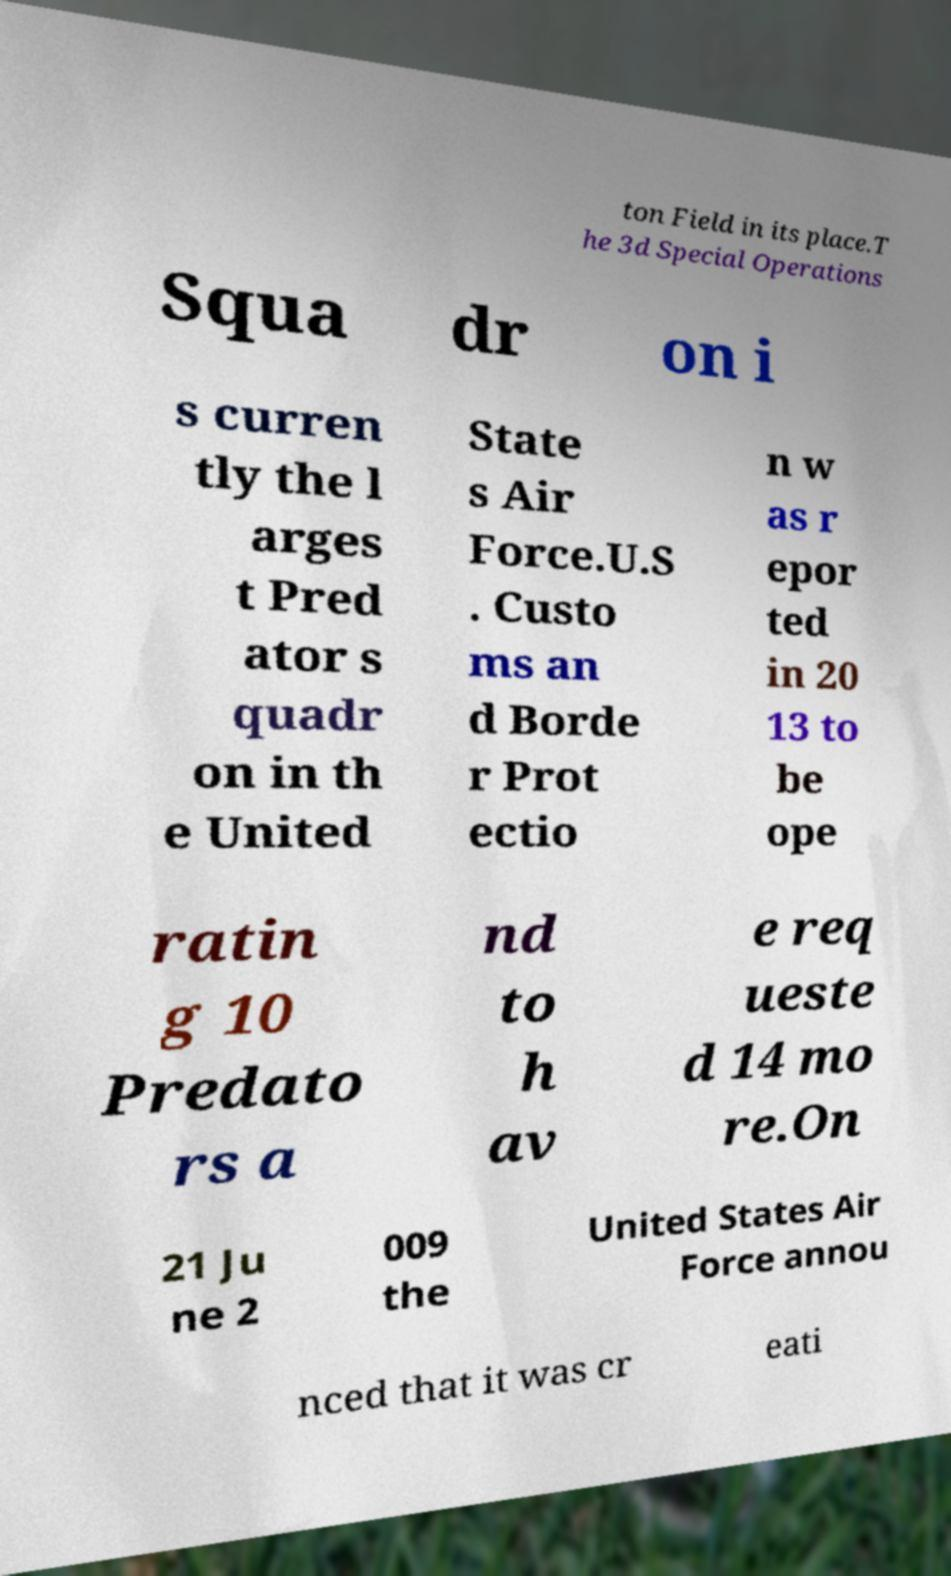Can you accurately transcribe the text from the provided image for me? ton Field in its place.T he 3d Special Operations Squa dr on i s curren tly the l arges t Pred ator s quadr on in th e United State s Air Force.U.S . Custo ms an d Borde r Prot ectio n w as r epor ted in 20 13 to be ope ratin g 10 Predato rs a nd to h av e req ueste d 14 mo re.On 21 Ju ne 2 009 the United States Air Force annou nced that it was cr eati 